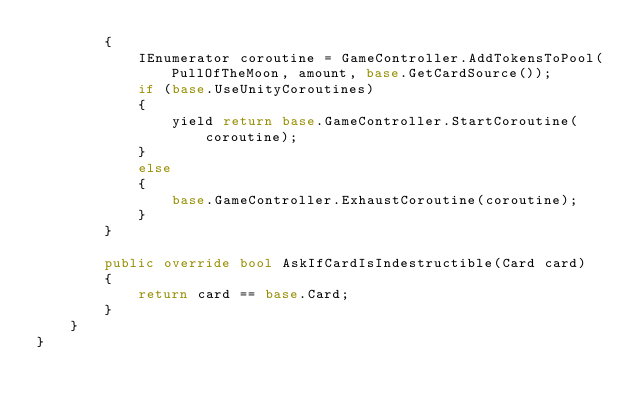Convert code to text. <code><loc_0><loc_0><loc_500><loc_500><_C#_>        {
            IEnumerator coroutine = GameController.AddTokensToPool(PullOfTheMoon, amount, base.GetCardSource());
            if (base.UseUnityCoroutines)
            {
                yield return base.GameController.StartCoroutine(coroutine);
            }
            else
            {
                base.GameController.ExhaustCoroutine(coroutine);
            }
        }

        public override bool AskIfCardIsIndestructible(Card card)
        {
            return card == base.Card;
        }
    }
}</code> 